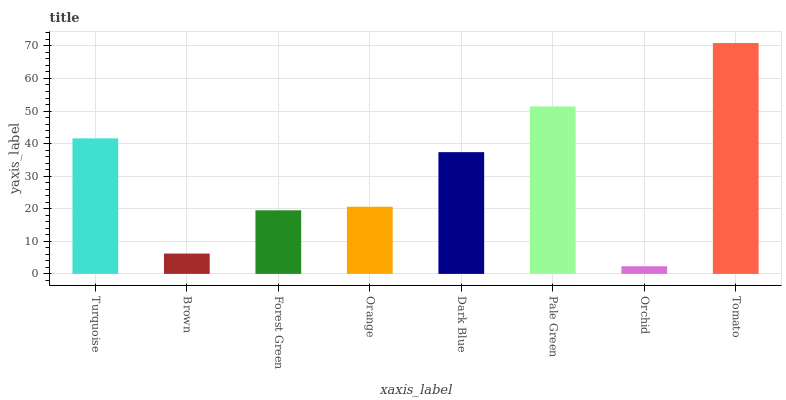Is Orchid the minimum?
Answer yes or no. Yes. Is Tomato the maximum?
Answer yes or no. Yes. Is Brown the minimum?
Answer yes or no. No. Is Brown the maximum?
Answer yes or no. No. Is Turquoise greater than Brown?
Answer yes or no. Yes. Is Brown less than Turquoise?
Answer yes or no. Yes. Is Brown greater than Turquoise?
Answer yes or no. No. Is Turquoise less than Brown?
Answer yes or no. No. Is Dark Blue the high median?
Answer yes or no. Yes. Is Orange the low median?
Answer yes or no. Yes. Is Pale Green the high median?
Answer yes or no. No. Is Brown the low median?
Answer yes or no. No. 